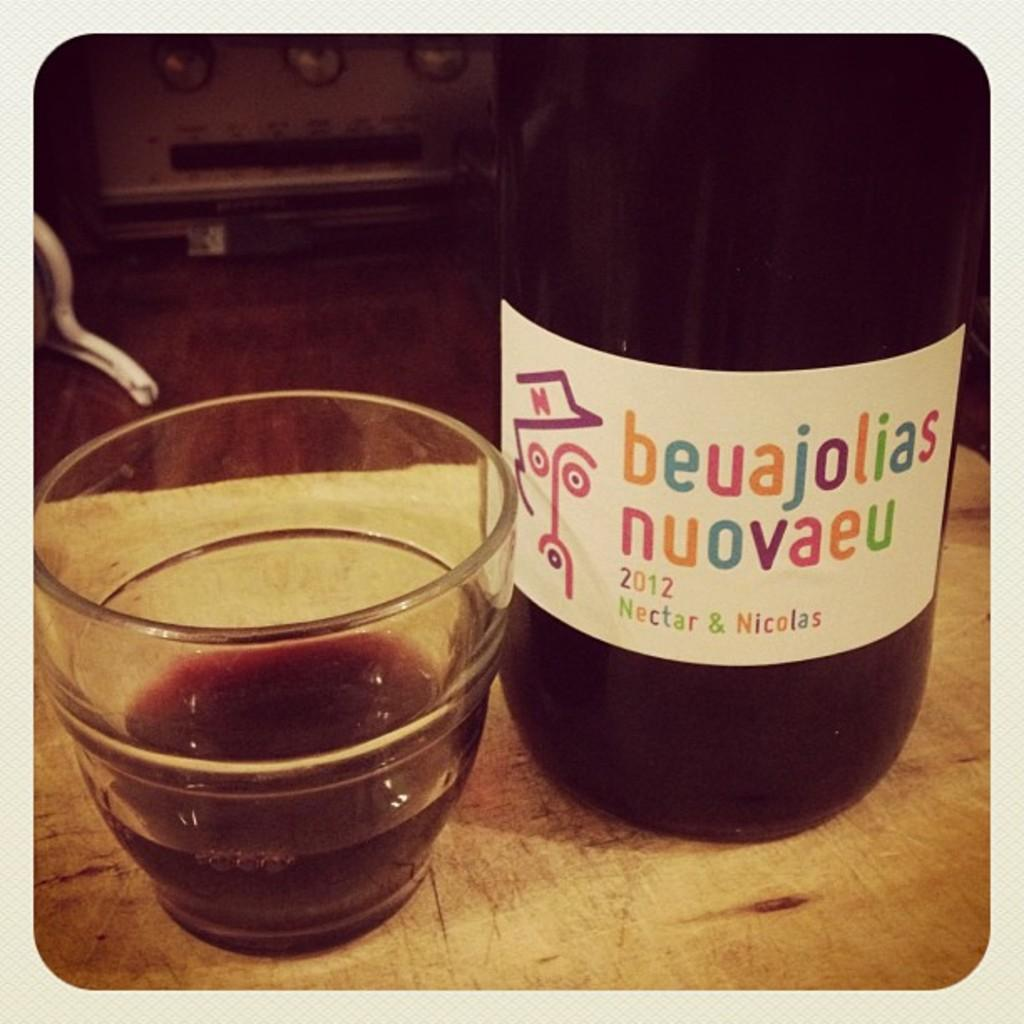<image>
Write a terse but informative summary of the picture. A bottle of 2019 beuajolias nuovaeu sits on a wooden plank next to a wine glass. 